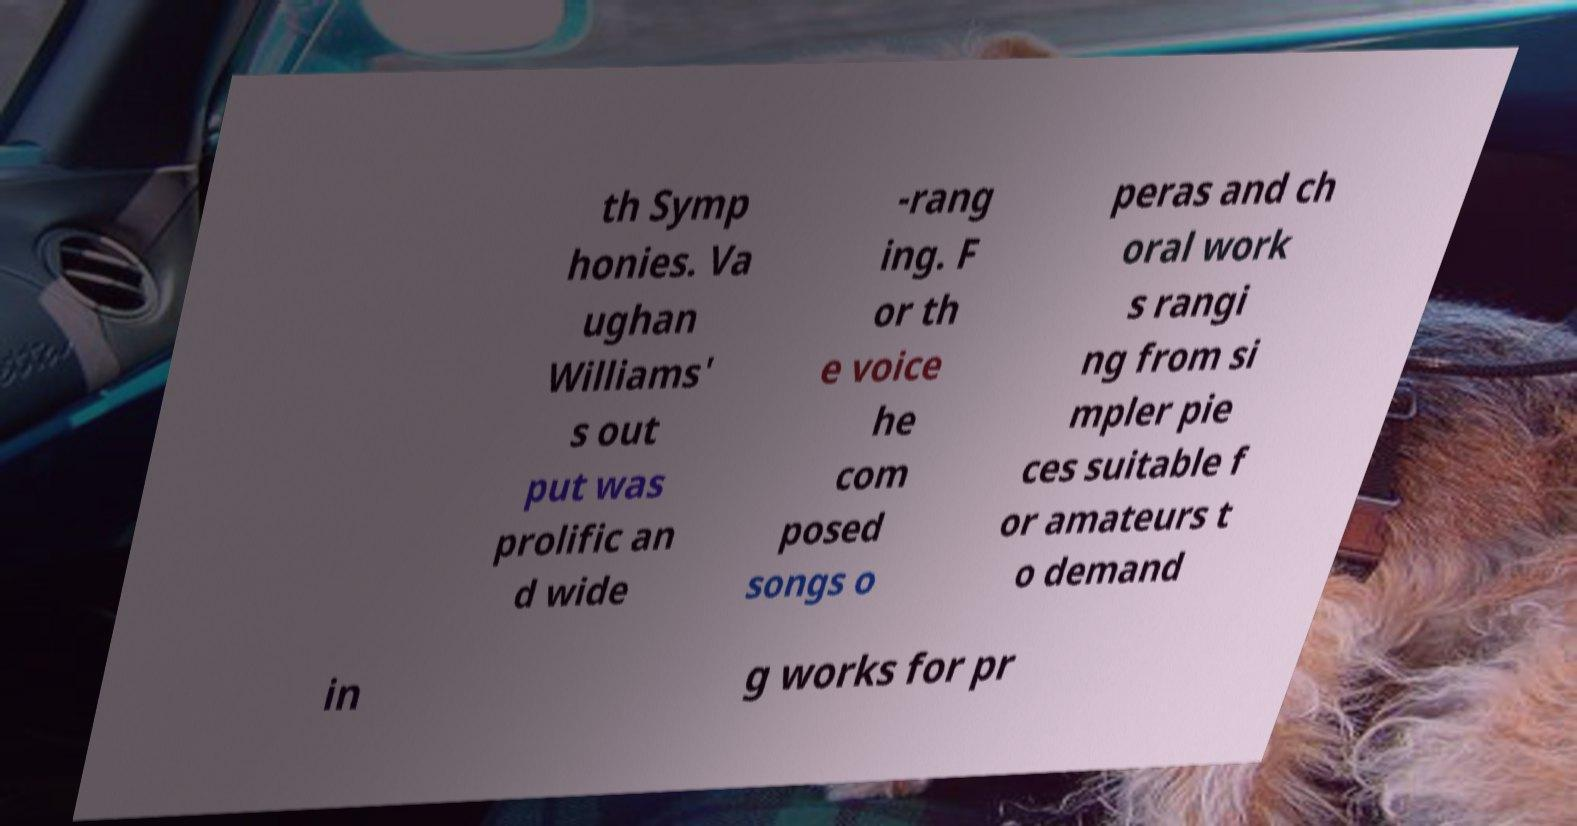Please identify and transcribe the text found in this image. th Symp honies. Va ughan Williams' s out put was prolific an d wide -rang ing. F or th e voice he com posed songs o peras and ch oral work s rangi ng from si mpler pie ces suitable f or amateurs t o demand in g works for pr 